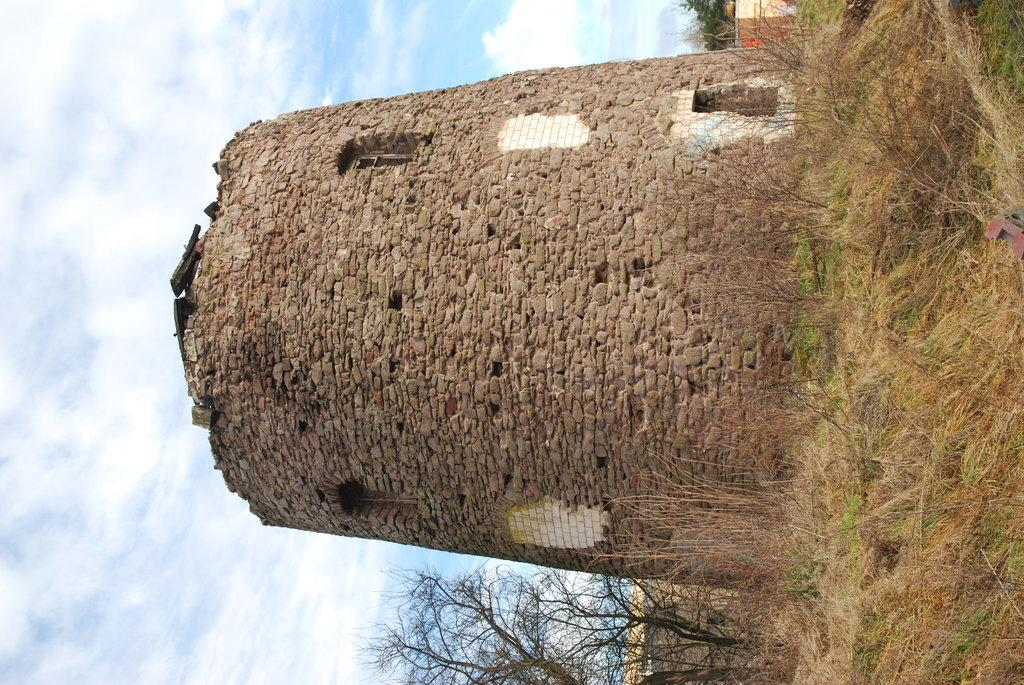What type of structure can be seen in the image? There is a wall in the image. What is a notable feature of the wall? The wall has windows. What material is the wall made of? The wall is made up of bricks. What type of vegetation is present at the bottom of the image? There is grass on the ground at the bottom of the image. What can be seen in the sky at the top of the image? There are clouds in the sky at the top of the image. What type of cord is hanging from the wall in the image? There is no cord hanging from the wall in the image. Is there a road visible in the image? No, there is no road visible in the image. 